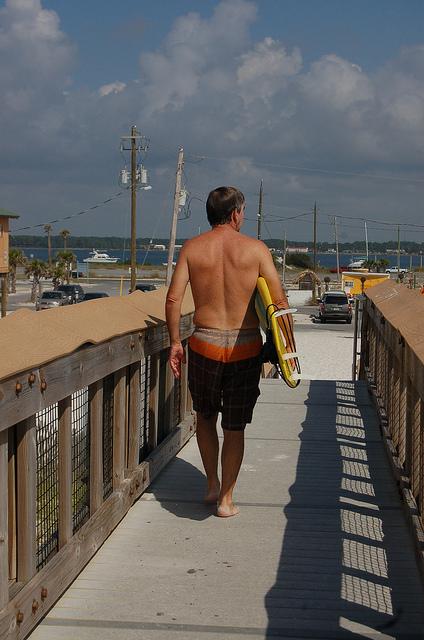Does this man have on a shirt?
Be succinct. No. What is the man carrying?
Quick response, please. Surfboard. Is the man going swimming?
Give a very brief answer. No. 